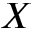<formula> <loc_0><loc_0><loc_500><loc_500>X</formula> 